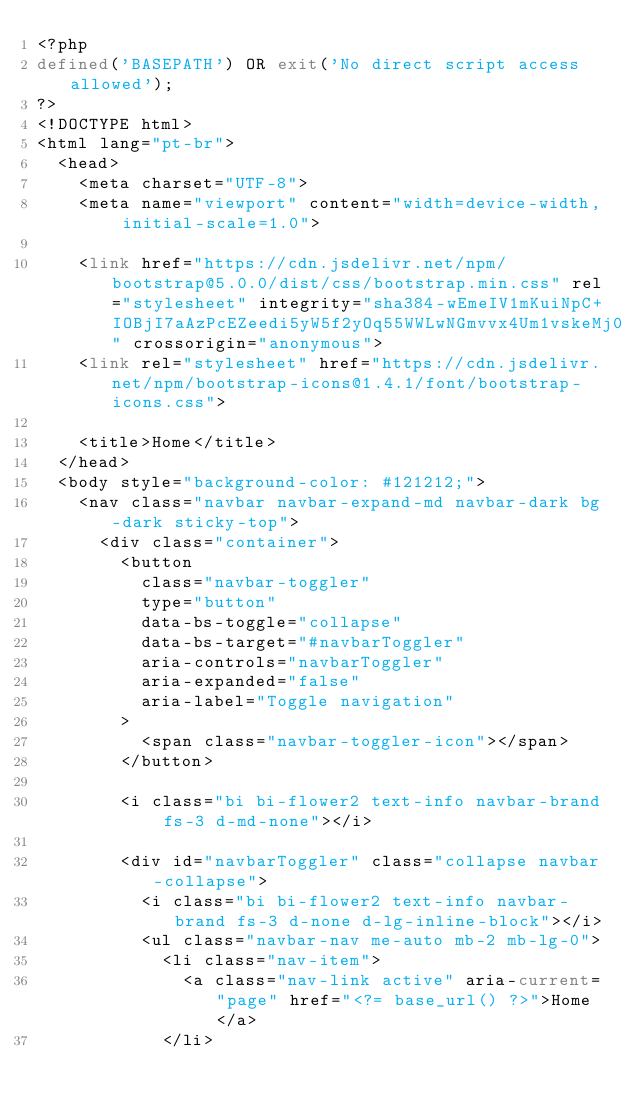Convert code to text. <code><loc_0><loc_0><loc_500><loc_500><_PHP_><?php
defined('BASEPATH') OR exit('No direct script access allowed');
?>
<!DOCTYPE html>
<html lang="pt-br">
  <head>
    <meta charset="UTF-8">
    <meta name="viewport" content="width=device-width, initial-scale=1.0">

    <link href="https://cdn.jsdelivr.net/npm/bootstrap@5.0.0/dist/css/bootstrap.min.css" rel="stylesheet" integrity="sha384-wEmeIV1mKuiNpC+IOBjI7aAzPcEZeedi5yW5f2yOq55WWLwNGmvvx4Um1vskeMj0" crossorigin="anonymous">
    <link rel="stylesheet" href="https://cdn.jsdelivr.net/npm/bootstrap-icons@1.4.1/font/bootstrap-icons.css">

    <title>Home</title>
  </head>
  <body style="background-color: #121212;">
    <nav class="navbar navbar-expand-md navbar-dark bg-dark sticky-top">
      <div class="container">
        <button
          class="navbar-toggler"
          type="button"
          data-bs-toggle="collapse"
          data-bs-target="#navbarToggler"
          aria-controls="navbarToggler"
          aria-expanded="false"
          aria-label="Toggle navigation"
        >
          <span class="navbar-toggler-icon"></span>
        </button>

        <i class="bi bi-flower2 text-info navbar-brand fs-3 d-md-none"></i>

        <div id="navbarToggler" class="collapse navbar-collapse">
          <i class="bi bi-flower2 text-info navbar-brand fs-3 d-none d-lg-inline-block"></i>
          <ul class="navbar-nav me-auto mb-2 mb-lg-0">
            <li class="nav-item">
              <a class="nav-link active" aria-current="page" href="<?= base_url() ?>">Home</a>
            </li></code> 